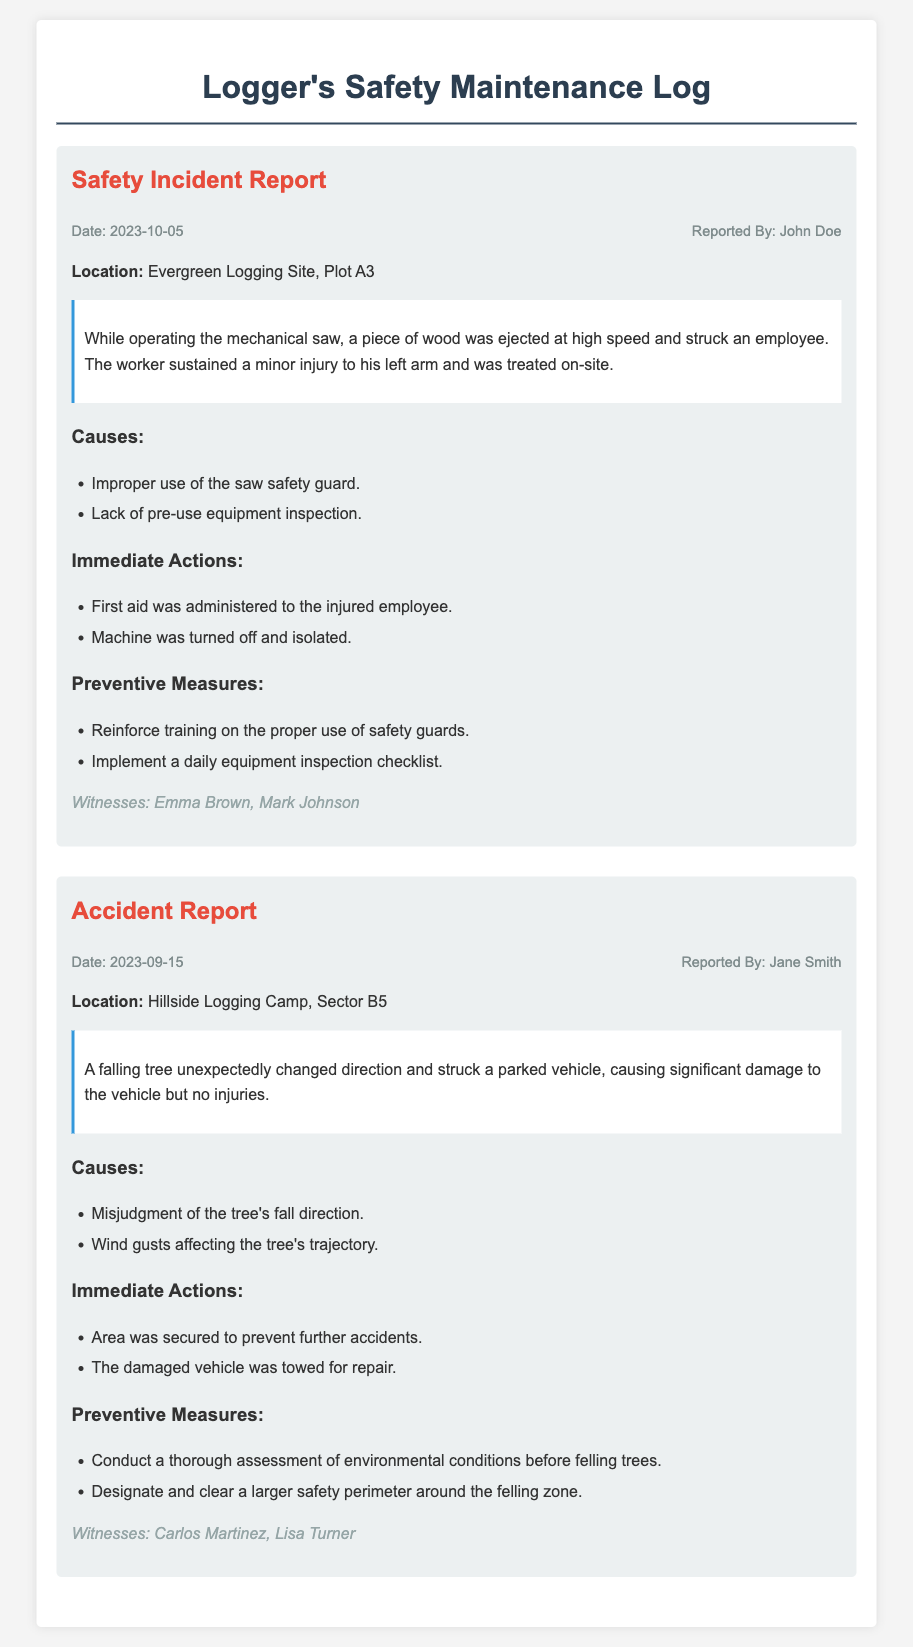what is the date of the safety incident? The date of the safety incident is explicitly mentioned in the report as 2023-10-05.
Answer: 2023-10-05 who reported the accident? The accident report states that Jane Smith reported the incident.
Answer: Jane Smith what was the location of the accident? The location of the accident is specified in the report as Hillside Logging Camp, Sector B5.
Answer: Hillside Logging Camp, Sector B5 what was the cause of the safety incident? The report lists two causes for the safety incident, including improper use of the saw safety guard.
Answer: Improper use of the saw safety guard who were the witnesses to the safety incident? The witnesses of the safety incident are mentioned as Emma Brown and Mark Johnson.
Answer: Emma Brown, Mark Johnson what immediate action was taken for the safety incident? The report details that first aid was administered to the injured employee as an immediate action.
Answer: First aid was administered to the injured employee what preventive measure was proposed after the accident? The report suggests conducting a thorough assessment of environmental conditions before felling trees as a preventive measure.
Answer: Conduct a thorough assessment of environmental conditions before felling trees what injury did the employee sustain in the safety incident? The employee sustained a minor injury to his left arm according to the incident report.
Answer: Minor injury to his left arm how many witnesses are listed in the accident report? The accident report provides names of two witnesses, Carlos Martinez and Lisa Turner.
Answer: Two witnesses 